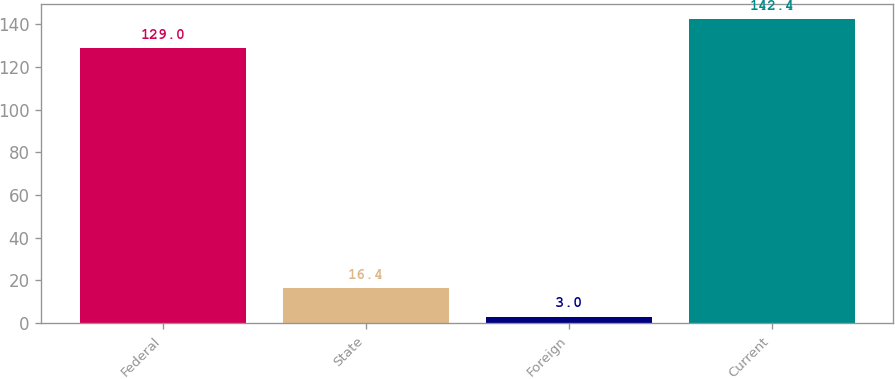Convert chart to OTSL. <chart><loc_0><loc_0><loc_500><loc_500><bar_chart><fcel>Federal<fcel>State<fcel>Foreign<fcel>Current<nl><fcel>129<fcel>16.4<fcel>3<fcel>142.4<nl></chart> 